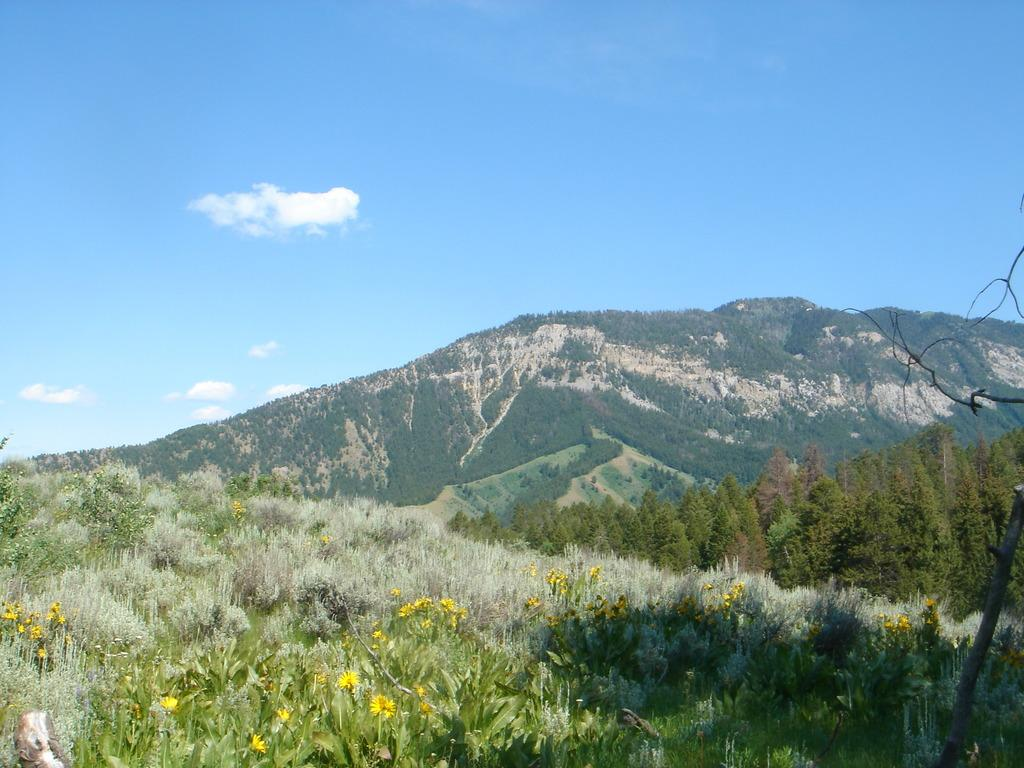What type of landscape is visible in the image? There is a beautiful view of mountains in the image. What other natural elements can be seen in the image? There are trees and flower plants in the image. What is visible in the sky in the image? Clouds are visible in the sky in the image. What type of plough is being used to cultivate the flower plants in the image? There is no plough present in the image; it features a beautiful view of mountains, trees, flower plants, and clouds in the sky. What is the distance between the mountains and the trees in the image? The provided facts do not give information about the distance between the mountains and the trees in the image. 